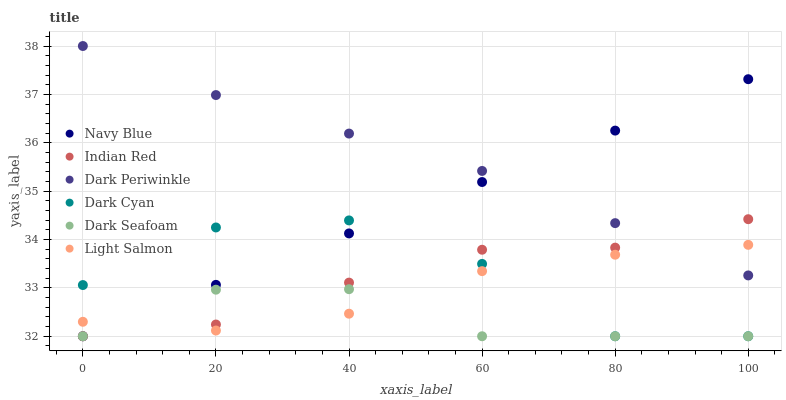Does Dark Seafoam have the minimum area under the curve?
Answer yes or no. Yes. Does Dark Periwinkle have the maximum area under the curve?
Answer yes or no. Yes. Does Navy Blue have the minimum area under the curve?
Answer yes or no. No. Does Navy Blue have the maximum area under the curve?
Answer yes or no. No. Is Navy Blue the smoothest?
Answer yes or no. Yes. Is Dark Cyan the roughest?
Answer yes or no. Yes. Is Dark Seafoam the smoothest?
Answer yes or no. No. Is Dark Seafoam the roughest?
Answer yes or no. No. Does Navy Blue have the lowest value?
Answer yes or no. Yes. Does Dark Periwinkle have the lowest value?
Answer yes or no. No. Does Dark Periwinkle have the highest value?
Answer yes or no. Yes. Does Navy Blue have the highest value?
Answer yes or no. No. Is Dark Cyan less than Dark Periwinkle?
Answer yes or no. Yes. Is Dark Periwinkle greater than Dark Seafoam?
Answer yes or no. Yes. Does Navy Blue intersect Dark Periwinkle?
Answer yes or no. Yes. Is Navy Blue less than Dark Periwinkle?
Answer yes or no. No. Is Navy Blue greater than Dark Periwinkle?
Answer yes or no. No. Does Dark Cyan intersect Dark Periwinkle?
Answer yes or no. No. 